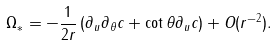Convert formula to latex. <formula><loc_0><loc_0><loc_500><loc_500>\Omega _ { * } = - \frac { 1 } { 2 r } \left ( \partial _ { u } \partial _ { \theta } c + \cot \theta \partial _ { u } c \right ) + O ( r ^ { - 2 } ) .</formula> 